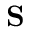<formula> <loc_0><loc_0><loc_500><loc_500>{ S }</formula> 